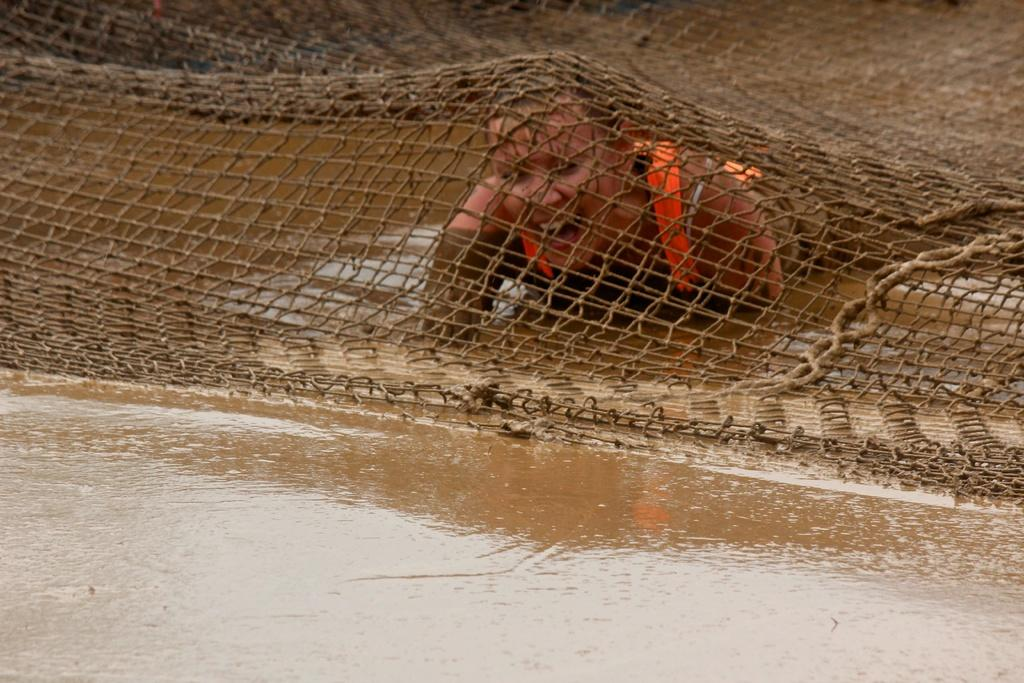Who or what is present in the image? There is a person in the image. What is the person wearing or holding in the image? The person has a net on them. What is the person's environment like in the image? The person is in the mud. What type of face cream is the person using in the image? There is no face cream present in the image; the person has a net on them and is in the mud. 